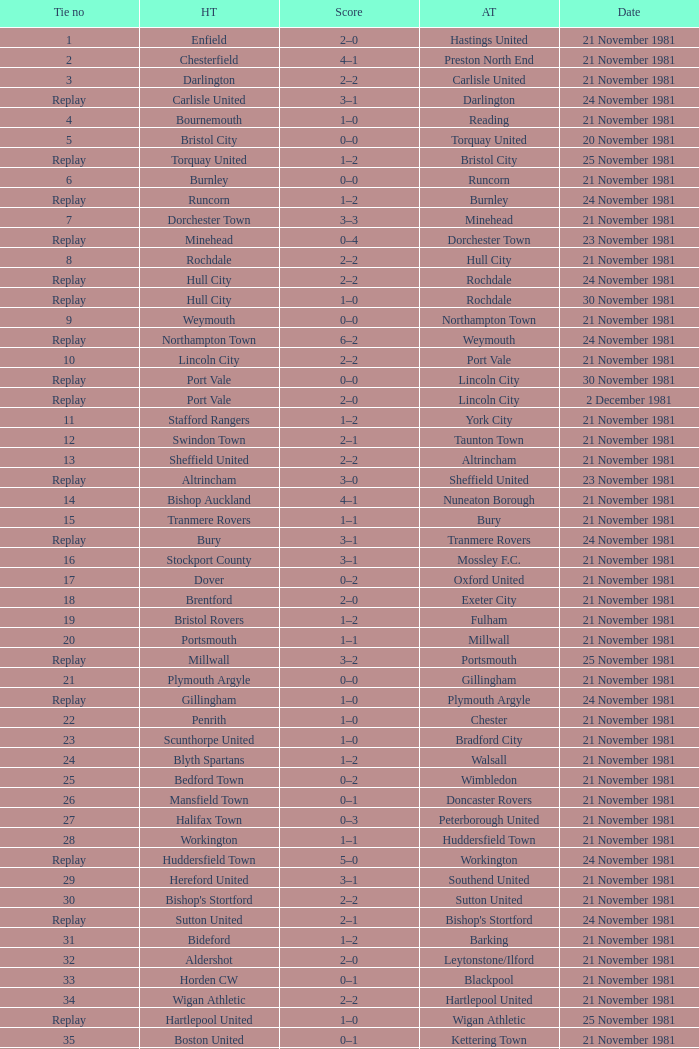On what date was tie number 4? 21 November 1981. 